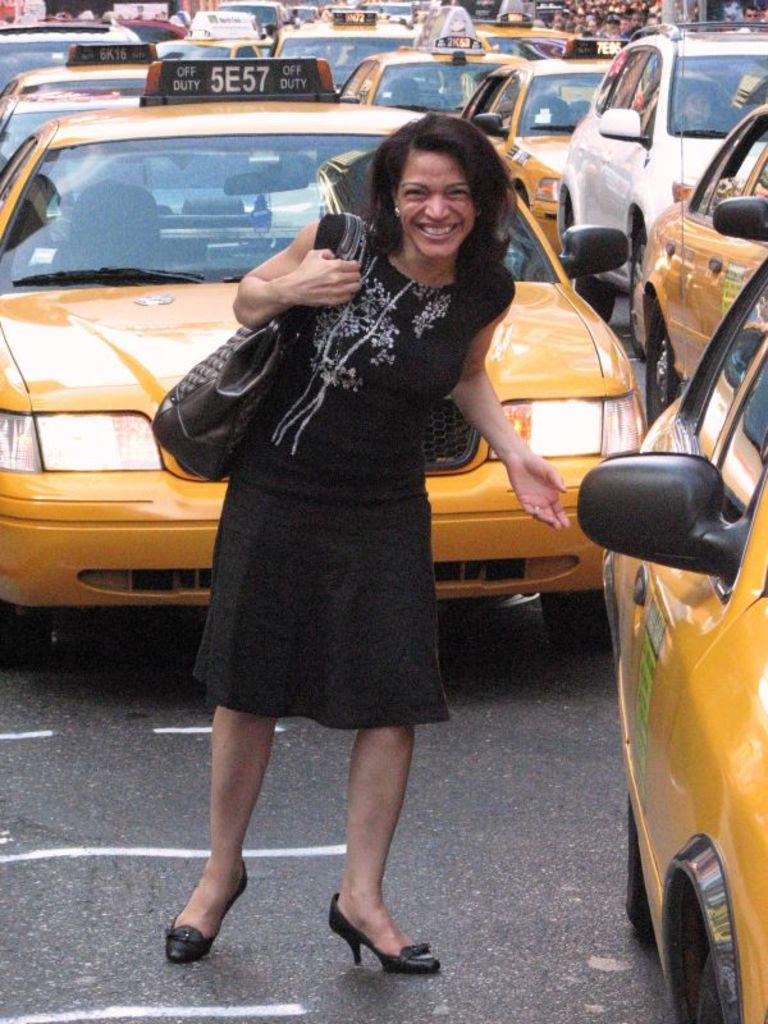What is the cab number?
Give a very brief answer. 5e57. The letters and numbers on the cab behind the girl say?
Give a very brief answer. 5e57. 